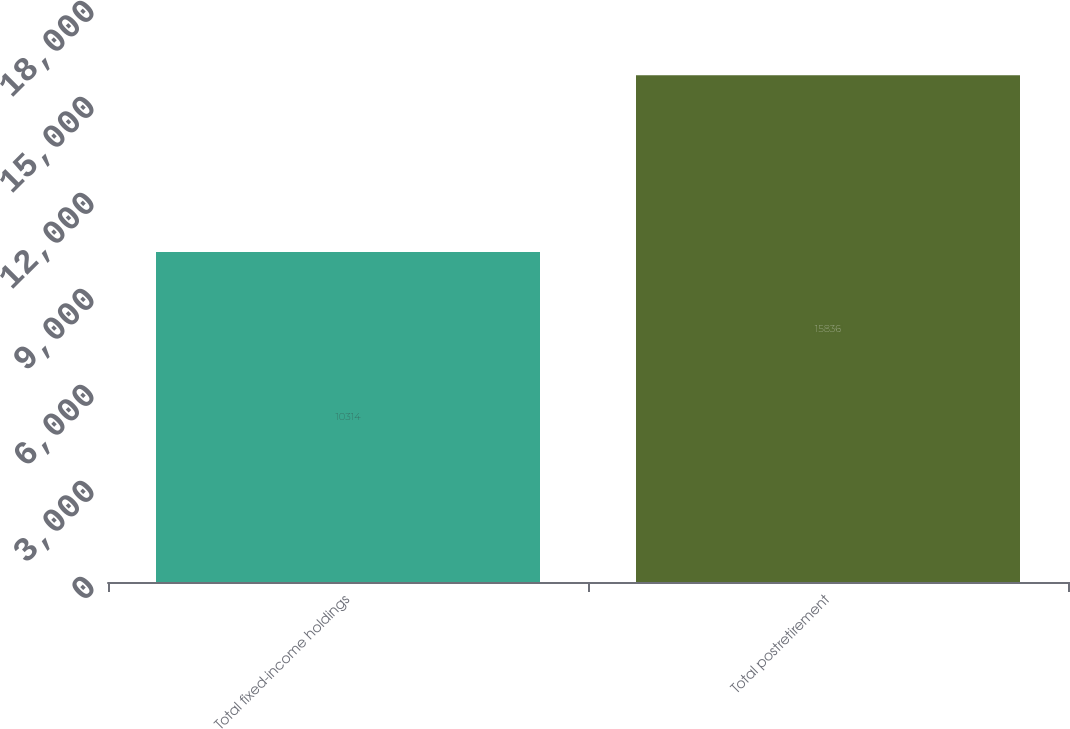Convert chart. <chart><loc_0><loc_0><loc_500><loc_500><bar_chart><fcel>Total fixed-income holdings<fcel>Total postretirement<nl><fcel>10314<fcel>15836<nl></chart> 